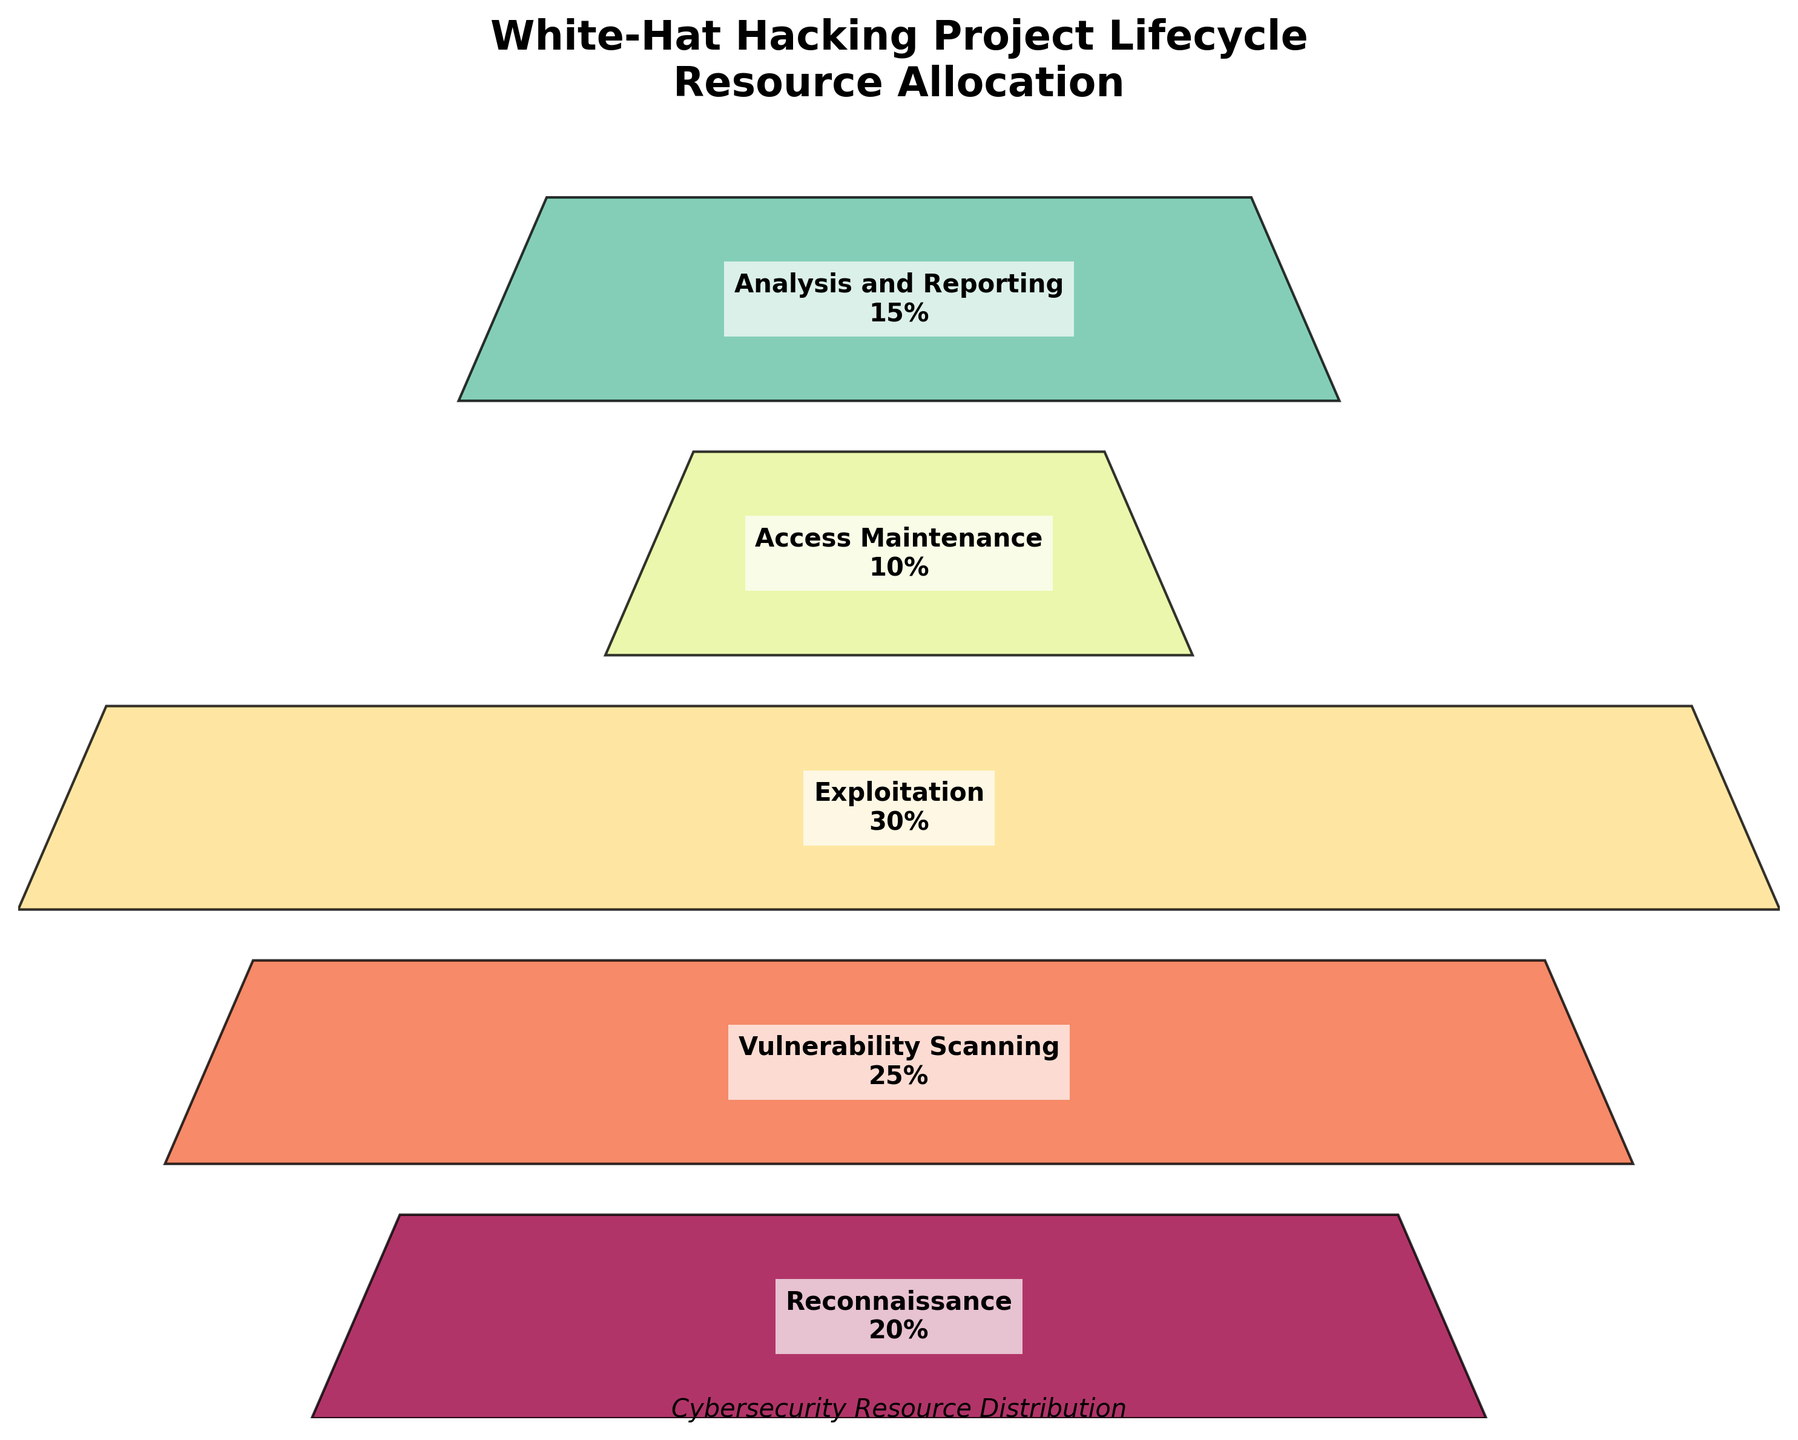What is the title of the funnel chart? The title is typically located at the top of the chart and gives an overall description of the data being presented. In this chart, it reads "White-Hat Hacking Project Lifecycle\nResource Allocation".
Answer: White-Hat Hacking Project Lifecycle Resource Allocation How many phases are included in the project lifecycle? Each phase is labeled on the chart within each segment of the funnel. By counting these, you can determine the number of phases. There are five labeled phases: Reconnaissance, Vulnerability Scanning, Exploitation, Access Maintenance, and Analysis and Reporting.
Answer: 5 Which phase has the highest percentage of resource allocation? The percentage of resource allocation is labeled within each segment of the funnel. The phase with the highest value is 30%, which corresponds to the Exploitation phase.
Answer: Exploitation What is the difference in resource allocation between the Vulnerability Scanning and Access Maintenance phases? The percentage of resource allocation for Vulnerability Scanning is 25%, and for Access Maintenance, it is 10%. Subtracting the latter from the former gives 25% - 10% = 15%.
Answer: 15% What is the average resource allocation across all phases? Add the percentages of each phase (20% + 25% + 30% + 10% + 15%) and divide by the number of phases (5). This calculation results in an average of (20 + 25 + 30 + 10 + 15) / 5 = 20%.
Answer: 20% Which phase allocates more resources: Reconnaissance or Analysis and Reporting? By checking the resource allocation percentages, Reconnaissance has 20% and Analysis and Reporting has 15%. Since 20% is greater than 15%, Reconnaissance allocates more resources.
Answer: Reconnaissance How do the shapes of the sections in the funnel chart visually represent the resources allocated to each phase? Each section's width is proportional to the resources allocated to that phase, with wider sections indicating higher resource allocation. The Exploitation phase is the widest, indicating the highest resource allocation, and Access Maintenance is narrower, indicating lower resources.
Answer: Width represents resources What is the combined resource allocation for Reconnaissance and Exploitation phases? Sum the resource percentages for Reconnaissance (20%) and Exploitation (30%). The combined resource allocation is 20% + 30% = 50%.
Answer: 50% How does the resource allocation for Vulnerability Scanning compare to Analysis and Reporting? Vulnerability Scanning has 25% resource allocation and Analysis and Reporting has 15%. Since 25% is greater than 15%, Vulnerability Scanning allocates more resources than Analysis and Reporting.
Answer: Vulnerability Scanning Which phase is the narrowest in the funnel chart and what does it indicate? The narrowest section in the funnel chart is the Access Maintenance phase, which indicates it has the lowest resource allocation at 10%.
Answer: Access Maintenance 